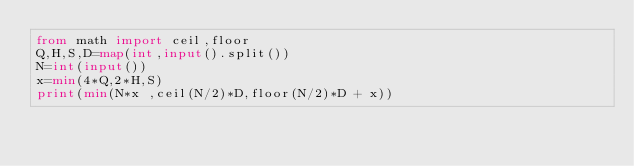<code> <loc_0><loc_0><loc_500><loc_500><_Python_>from math import ceil,floor
Q,H,S,D=map(int,input().split())
N=int(input())
x=min(4*Q,2*H,S)
print(min(N*x ,ceil(N/2)*D,floor(N/2)*D + x))</code> 